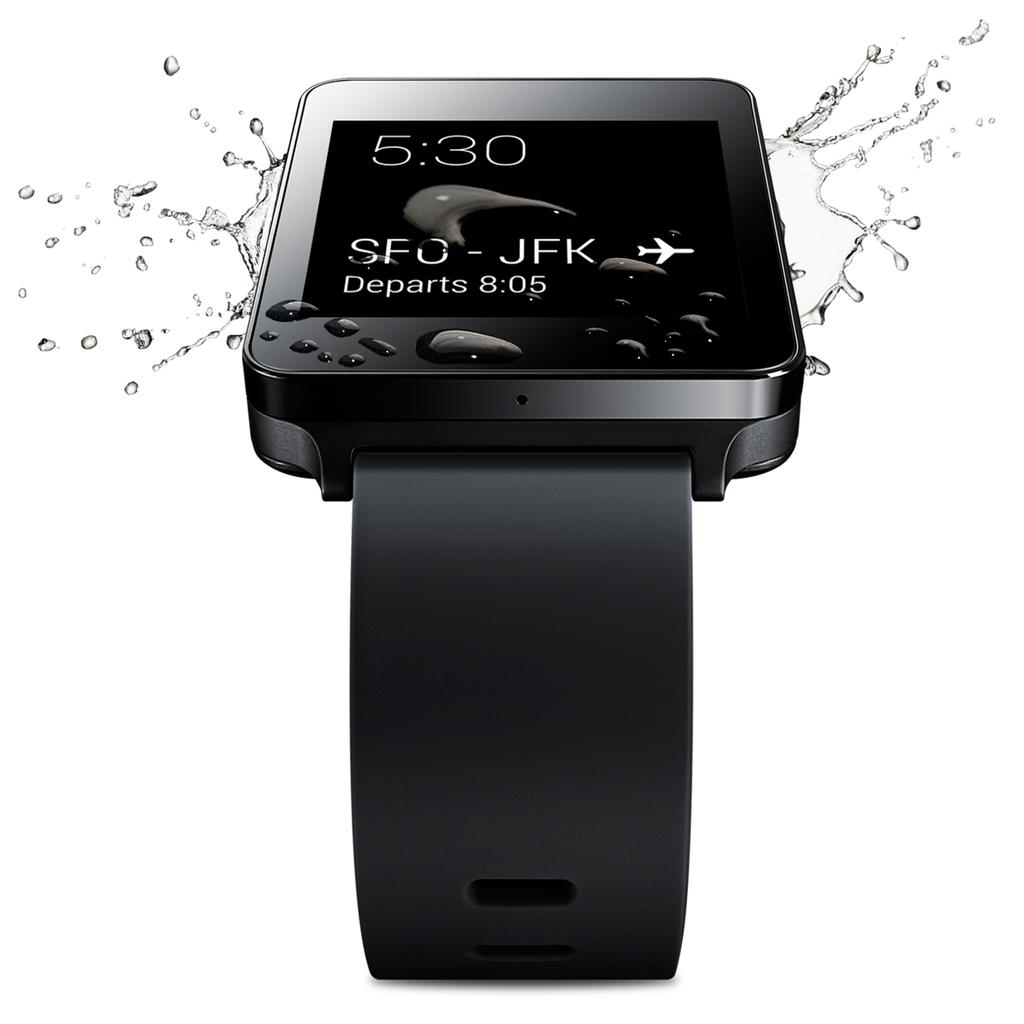<image>
Summarize the visual content of the image. A black watch that is waterproof shows that the time is 5:30. 